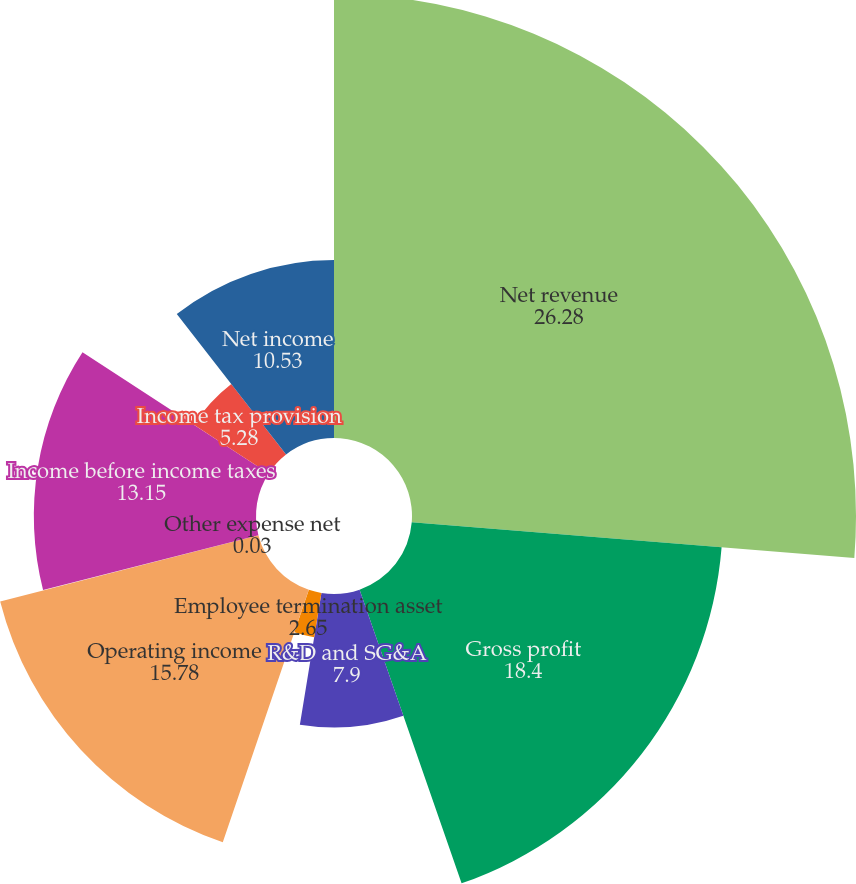<chart> <loc_0><loc_0><loc_500><loc_500><pie_chart><fcel>Net revenue<fcel>Gross profit<fcel>R&D and SG&A<fcel>Employee termination asset<fcel>Operating income<fcel>Other expense net<fcel>Income before income taxes<fcel>Income tax provision<fcel>Net income<nl><fcel>26.28%<fcel>18.4%<fcel>7.9%<fcel>2.65%<fcel>15.78%<fcel>0.03%<fcel>13.15%<fcel>5.28%<fcel>10.53%<nl></chart> 